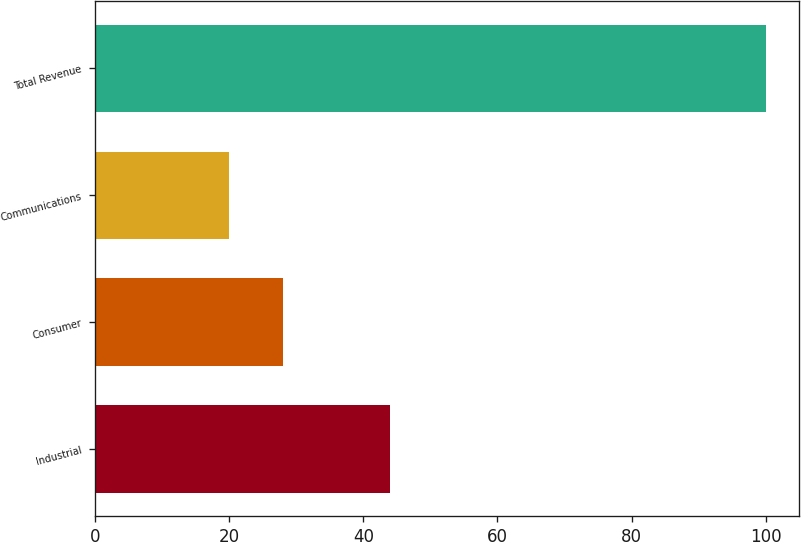Convert chart. <chart><loc_0><loc_0><loc_500><loc_500><bar_chart><fcel>Industrial<fcel>Consumer<fcel>Communications<fcel>Total Revenue<nl><fcel>44<fcel>28<fcel>20<fcel>100<nl></chart> 